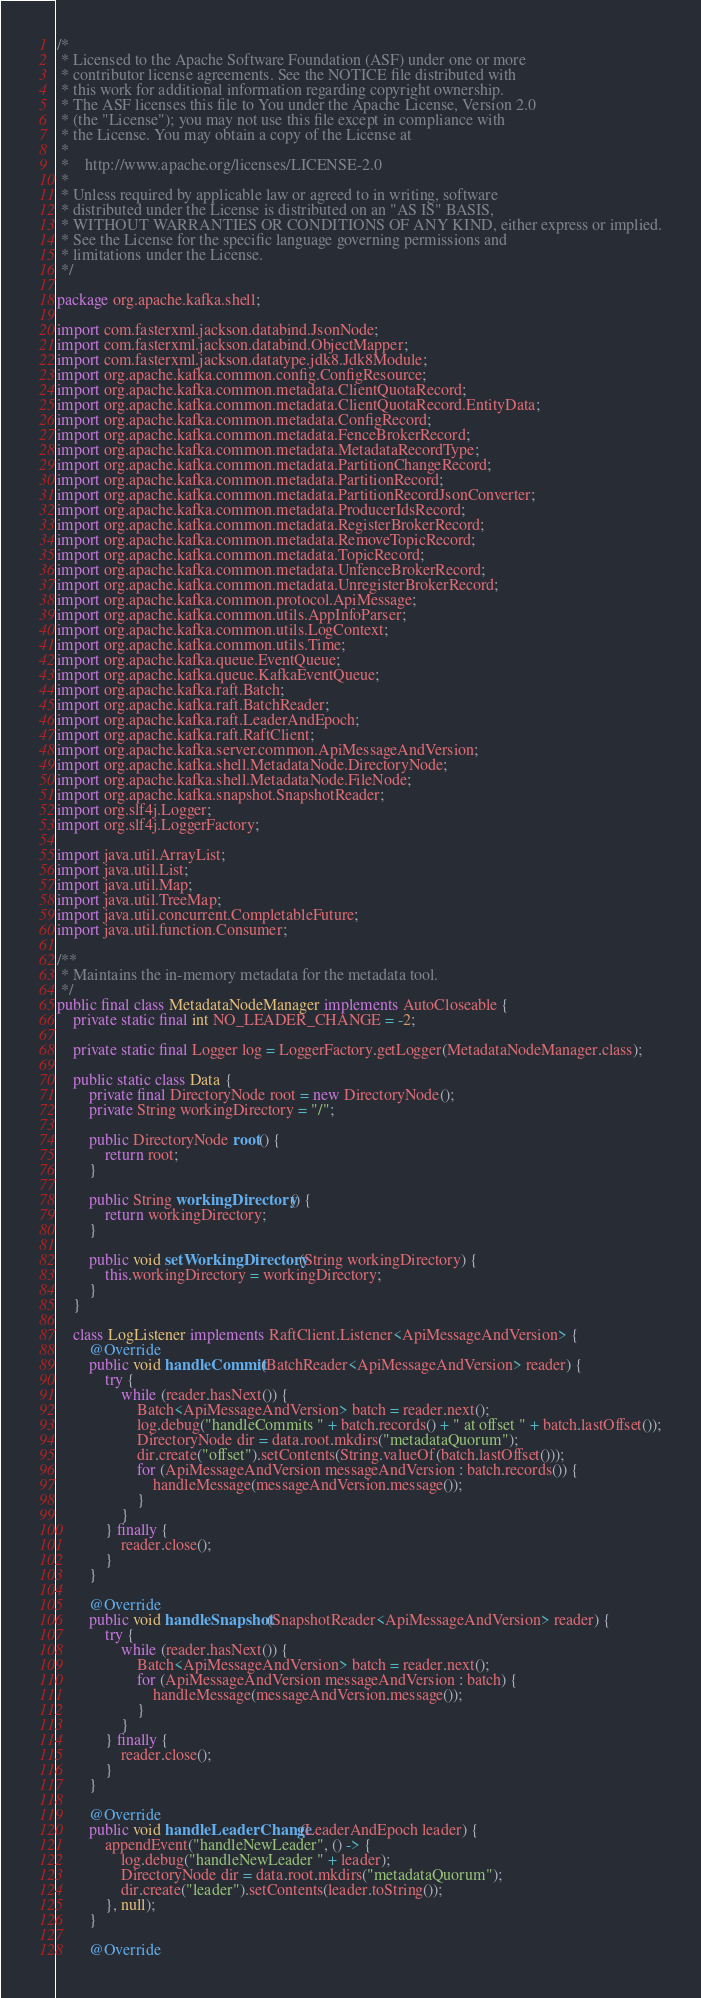<code> <loc_0><loc_0><loc_500><loc_500><_Java_>/*
 * Licensed to the Apache Software Foundation (ASF) under one or more
 * contributor license agreements. See the NOTICE file distributed with
 * this work for additional information regarding copyright ownership.
 * The ASF licenses this file to You under the Apache License, Version 2.0
 * (the "License"); you may not use this file except in compliance with
 * the License. You may obtain a copy of the License at
 *
 *    http://www.apache.org/licenses/LICENSE-2.0
 *
 * Unless required by applicable law or agreed to in writing, software
 * distributed under the License is distributed on an "AS IS" BASIS,
 * WITHOUT WARRANTIES OR CONDITIONS OF ANY KIND, either express or implied.
 * See the License for the specific language governing permissions and
 * limitations under the License.
 */

package org.apache.kafka.shell;

import com.fasterxml.jackson.databind.JsonNode;
import com.fasterxml.jackson.databind.ObjectMapper;
import com.fasterxml.jackson.datatype.jdk8.Jdk8Module;
import org.apache.kafka.common.config.ConfigResource;
import org.apache.kafka.common.metadata.ClientQuotaRecord;
import org.apache.kafka.common.metadata.ClientQuotaRecord.EntityData;
import org.apache.kafka.common.metadata.ConfigRecord;
import org.apache.kafka.common.metadata.FenceBrokerRecord;
import org.apache.kafka.common.metadata.MetadataRecordType;
import org.apache.kafka.common.metadata.PartitionChangeRecord;
import org.apache.kafka.common.metadata.PartitionRecord;
import org.apache.kafka.common.metadata.PartitionRecordJsonConverter;
import org.apache.kafka.common.metadata.ProducerIdsRecord;
import org.apache.kafka.common.metadata.RegisterBrokerRecord;
import org.apache.kafka.common.metadata.RemoveTopicRecord;
import org.apache.kafka.common.metadata.TopicRecord;
import org.apache.kafka.common.metadata.UnfenceBrokerRecord;
import org.apache.kafka.common.metadata.UnregisterBrokerRecord;
import org.apache.kafka.common.protocol.ApiMessage;
import org.apache.kafka.common.utils.AppInfoParser;
import org.apache.kafka.common.utils.LogContext;
import org.apache.kafka.common.utils.Time;
import org.apache.kafka.queue.EventQueue;
import org.apache.kafka.queue.KafkaEventQueue;
import org.apache.kafka.raft.Batch;
import org.apache.kafka.raft.BatchReader;
import org.apache.kafka.raft.LeaderAndEpoch;
import org.apache.kafka.raft.RaftClient;
import org.apache.kafka.server.common.ApiMessageAndVersion;
import org.apache.kafka.shell.MetadataNode.DirectoryNode;
import org.apache.kafka.shell.MetadataNode.FileNode;
import org.apache.kafka.snapshot.SnapshotReader;
import org.slf4j.Logger;
import org.slf4j.LoggerFactory;

import java.util.ArrayList;
import java.util.List;
import java.util.Map;
import java.util.TreeMap;
import java.util.concurrent.CompletableFuture;
import java.util.function.Consumer;

/**
 * Maintains the in-memory metadata for the metadata tool.
 */
public final class MetadataNodeManager implements AutoCloseable {
    private static final int NO_LEADER_CHANGE = -2;

    private static final Logger log = LoggerFactory.getLogger(MetadataNodeManager.class);

    public static class Data {
        private final DirectoryNode root = new DirectoryNode();
        private String workingDirectory = "/";

        public DirectoryNode root() {
            return root;
        }

        public String workingDirectory() {
            return workingDirectory;
        }

        public void setWorkingDirectory(String workingDirectory) {
            this.workingDirectory = workingDirectory;
        }
    }

    class LogListener implements RaftClient.Listener<ApiMessageAndVersion> {
        @Override
        public void handleCommit(BatchReader<ApiMessageAndVersion> reader) {
            try {
                while (reader.hasNext()) {
                    Batch<ApiMessageAndVersion> batch = reader.next();
                    log.debug("handleCommits " + batch.records() + " at offset " + batch.lastOffset());
                    DirectoryNode dir = data.root.mkdirs("metadataQuorum");
                    dir.create("offset").setContents(String.valueOf(batch.lastOffset()));
                    for (ApiMessageAndVersion messageAndVersion : batch.records()) {
                        handleMessage(messageAndVersion.message());
                    }
                }
            } finally {
                reader.close();
            }
        }

        @Override
        public void handleSnapshot(SnapshotReader<ApiMessageAndVersion> reader) {
            try {
                while (reader.hasNext()) {
                    Batch<ApiMessageAndVersion> batch = reader.next();
                    for (ApiMessageAndVersion messageAndVersion : batch) {
                        handleMessage(messageAndVersion.message());
                    }
                }
            } finally {
                reader.close();
            }
        }

        @Override
        public void handleLeaderChange(LeaderAndEpoch leader) {
            appendEvent("handleNewLeader", () -> {
                log.debug("handleNewLeader " + leader);
                DirectoryNode dir = data.root.mkdirs("metadataQuorum");
                dir.create("leader").setContents(leader.toString());
            }, null);
        }

        @Override</code> 